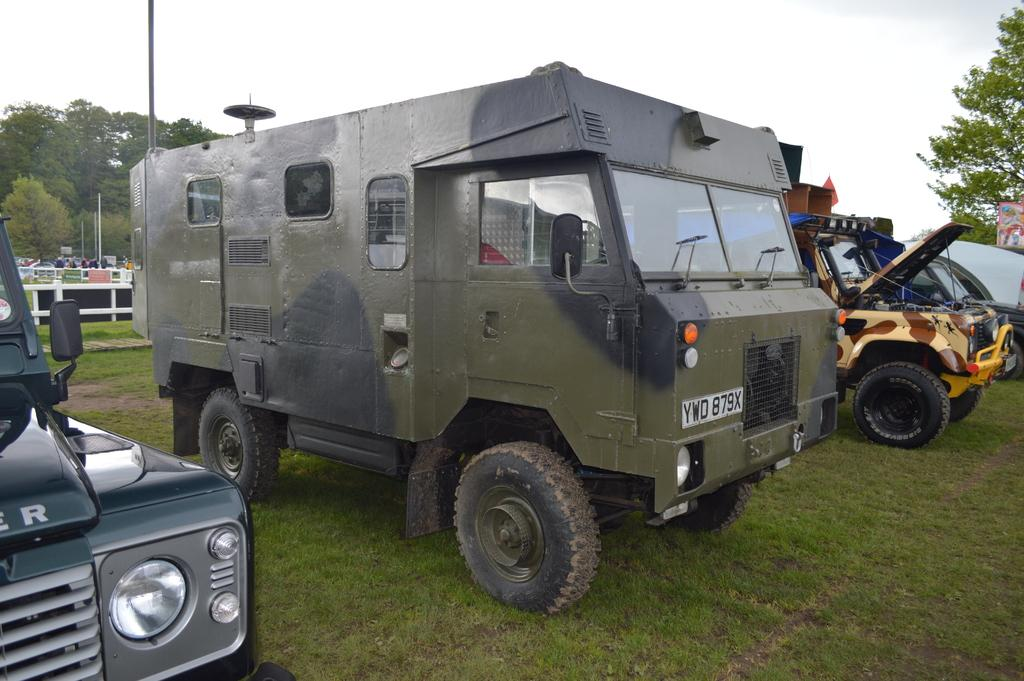What is on the ground in the image? There are vehicles parked on the ground in the image. What type of surface is the ground made of? The ground has grass on it in the image. What can be seen in the background of the image? There are trees and the sky visible in the background of the image. What type of match is being played in the image? There is no match being played in the image; it features vehicles parked on grass with trees and the sky in the background. What kind of oatmeal is being served in the image? There is no oatmeal present in the image. 